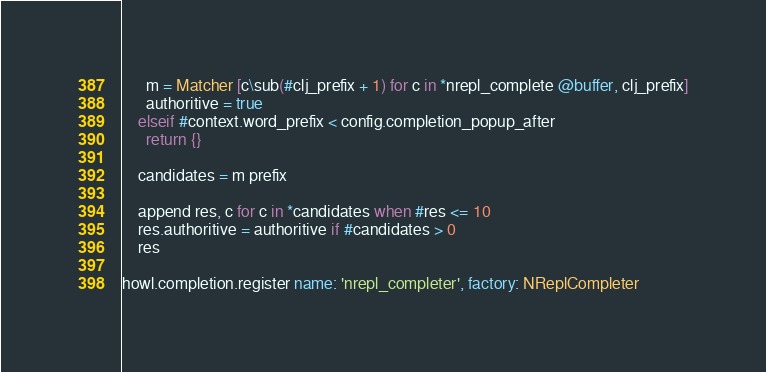Convert code to text. <code><loc_0><loc_0><loc_500><loc_500><_MoonScript_>      m = Matcher [c\sub(#clj_prefix + 1) for c in *nrepl_complete @buffer, clj_prefix]
      authoritive = true
    elseif #context.word_prefix < config.completion_popup_after
      return {}

    candidates = m prefix

    append res, c for c in *candidates when #res <= 10
    res.authoritive = authoritive if #candidates > 0
    res

howl.completion.register name: 'nrepl_completer', factory: NReplCompleter
</code> 